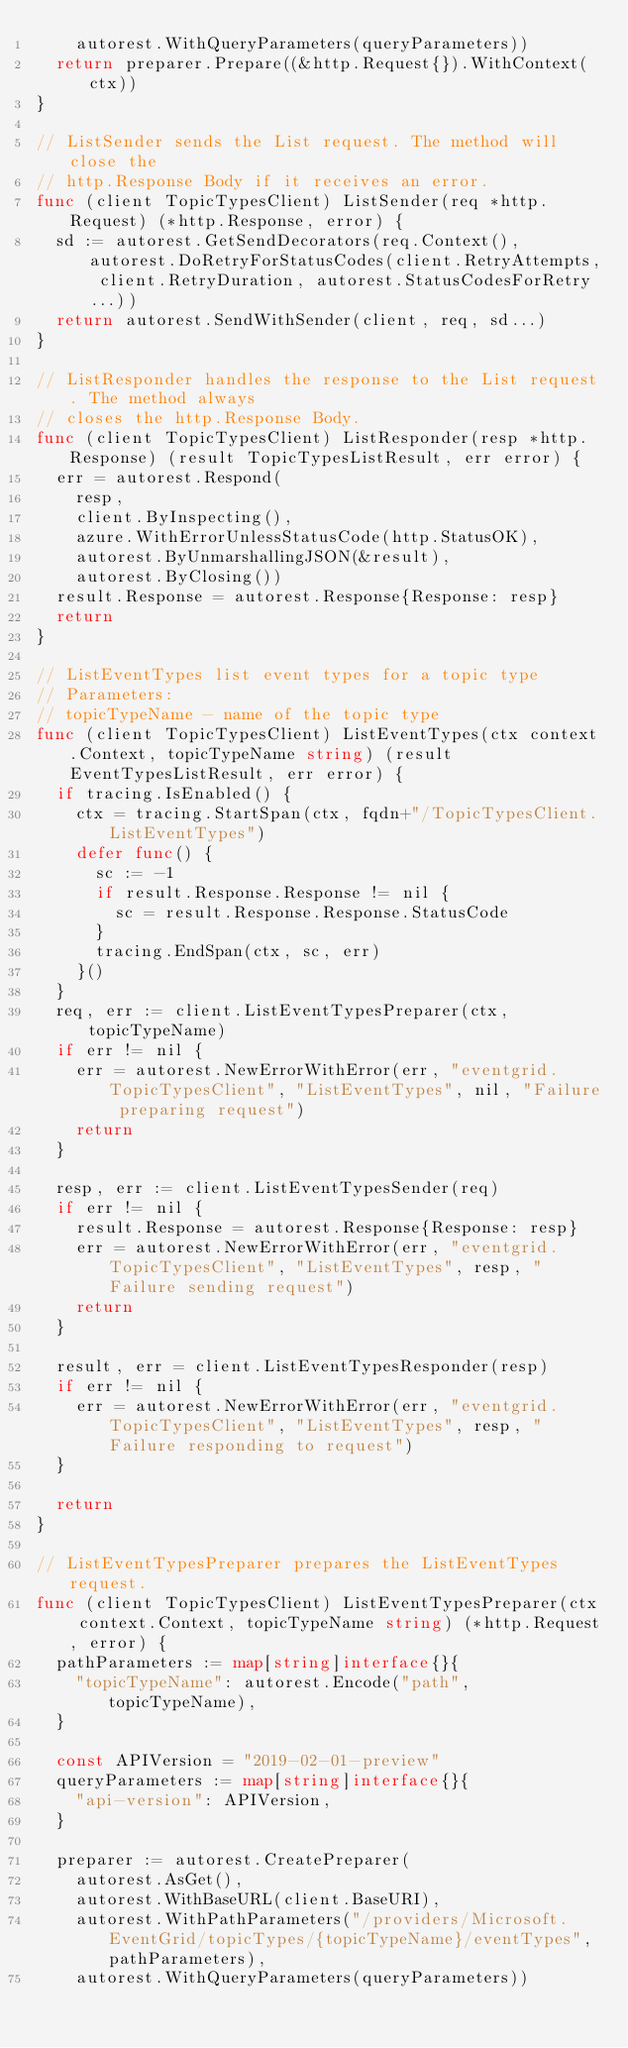Convert code to text. <code><loc_0><loc_0><loc_500><loc_500><_Go_>		autorest.WithQueryParameters(queryParameters))
	return preparer.Prepare((&http.Request{}).WithContext(ctx))
}

// ListSender sends the List request. The method will close the
// http.Response Body if it receives an error.
func (client TopicTypesClient) ListSender(req *http.Request) (*http.Response, error) {
	sd := autorest.GetSendDecorators(req.Context(), autorest.DoRetryForStatusCodes(client.RetryAttempts, client.RetryDuration, autorest.StatusCodesForRetry...))
	return autorest.SendWithSender(client, req, sd...)
}

// ListResponder handles the response to the List request. The method always
// closes the http.Response Body.
func (client TopicTypesClient) ListResponder(resp *http.Response) (result TopicTypesListResult, err error) {
	err = autorest.Respond(
		resp,
		client.ByInspecting(),
		azure.WithErrorUnlessStatusCode(http.StatusOK),
		autorest.ByUnmarshallingJSON(&result),
		autorest.ByClosing())
	result.Response = autorest.Response{Response: resp}
	return
}

// ListEventTypes list event types for a topic type
// Parameters:
// topicTypeName - name of the topic type
func (client TopicTypesClient) ListEventTypes(ctx context.Context, topicTypeName string) (result EventTypesListResult, err error) {
	if tracing.IsEnabled() {
		ctx = tracing.StartSpan(ctx, fqdn+"/TopicTypesClient.ListEventTypes")
		defer func() {
			sc := -1
			if result.Response.Response != nil {
				sc = result.Response.Response.StatusCode
			}
			tracing.EndSpan(ctx, sc, err)
		}()
	}
	req, err := client.ListEventTypesPreparer(ctx, topicTypeName)
	if err != nil {
		err = autorest.NewErrorWithError(err, "eventgrid.TopicTypesClient", "ListEventTypes", nil, "Failure preparing request")
		return
	}

	resp, err := client.ListEventTypesSender(req)
	if err != nil {
		result.Response = autorest.Response{Response: resp}
		err = autorest.NewErrorWithError(err, "eventgrid.TopicTypesClient", "ListEventTypes", resp, "Failure sending request")
		return
	}

	result, err = client.ListEventTypesResponder(resp)
	if err != nil {
		err = autorest.NewErrorWithError(err, "eventgrid.TopicTypesClient", "ListEventTypes", resp, "Failure responding to request")
	}

	return
}

// ListEventTypesPreparer prepares the ListEventTypes request.
func (client TopicTypesClient) ListEventTypesPreparer(ctx context.Context, topicTypeName string) (*http.Request, error) {
	pathParameters := map[string]interface{}{
		"topicTypeName": autorest.Encode("path", topicTypeName),
	}

	const APIVersion = "2019-02-01-preview"
	queryParameters := map[string]interface{}{
		"api-version": APIVersion,
	}

	preparer := autorest.CreatePreparer(
		autorest.AsGet(),
		autorest.WithBaseURL(client.BaseURI),
		autorest.WithPathParameters("/providers/Microsoft.EventGrid/topicTypes/{topicTypeName}/eventTypes", pathParameters),
		autorest.WithQueryParameters(queryParameters))</code> 